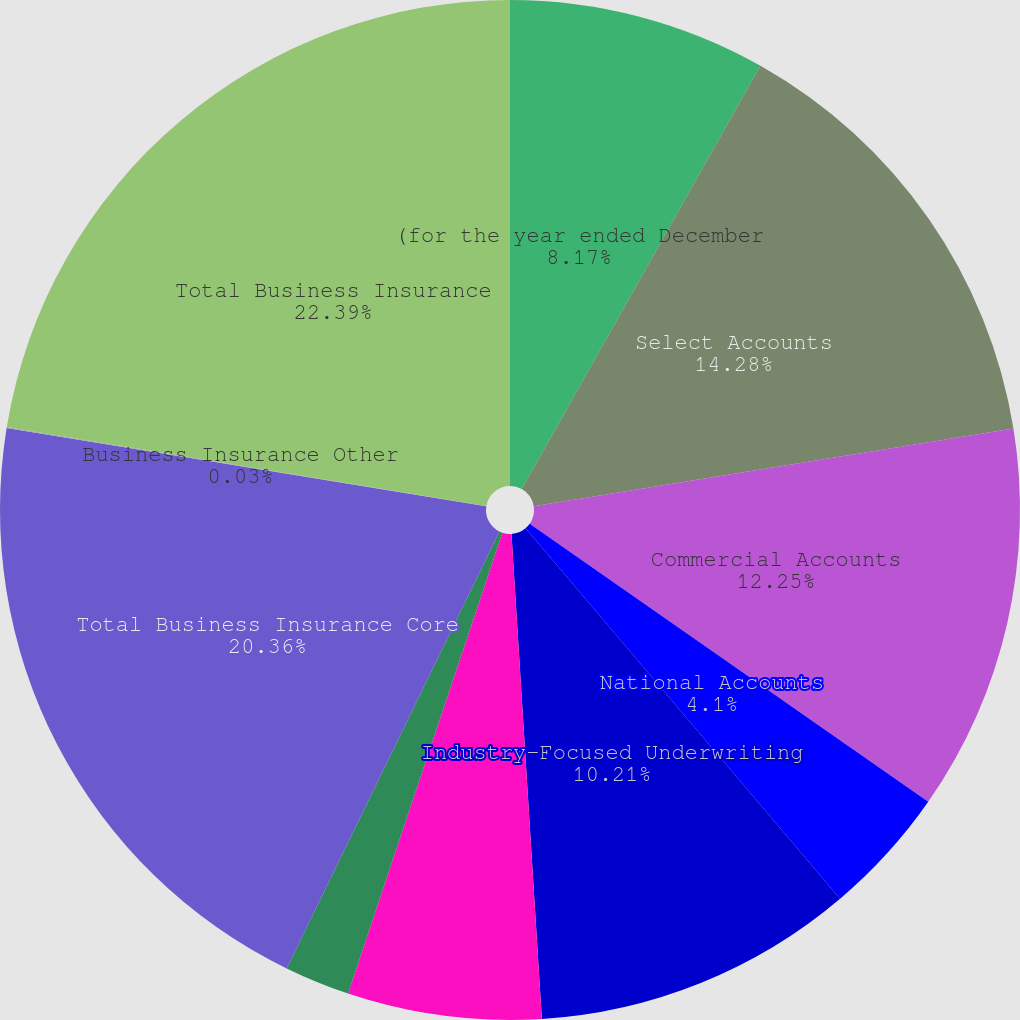Convert chart. <chart><loc_0><loc_0><loc_500><loc_500><pie_chart><fcel>(for the year ended December<fcel>Select Accounts<fcel>Commercial Accounts<fcel>National Accounts<fcel>Industry-Focused Underwriting<fcel>Target Risk Underwriting<fcel>Specialized Distribution<fcel>Total Business Insurance Core<fcel>Business Insurance Other<fcel>Total Business Insurance<nl><fcel>8.17%<fcel>14.28%<fcel>12.25%<fcel>4.1%<fcel>10.21%<fcel>6.14%<fcel>2.07%<fcel>20.36%<fcel>0.03%<fcel>22.4%<nl></chart> 